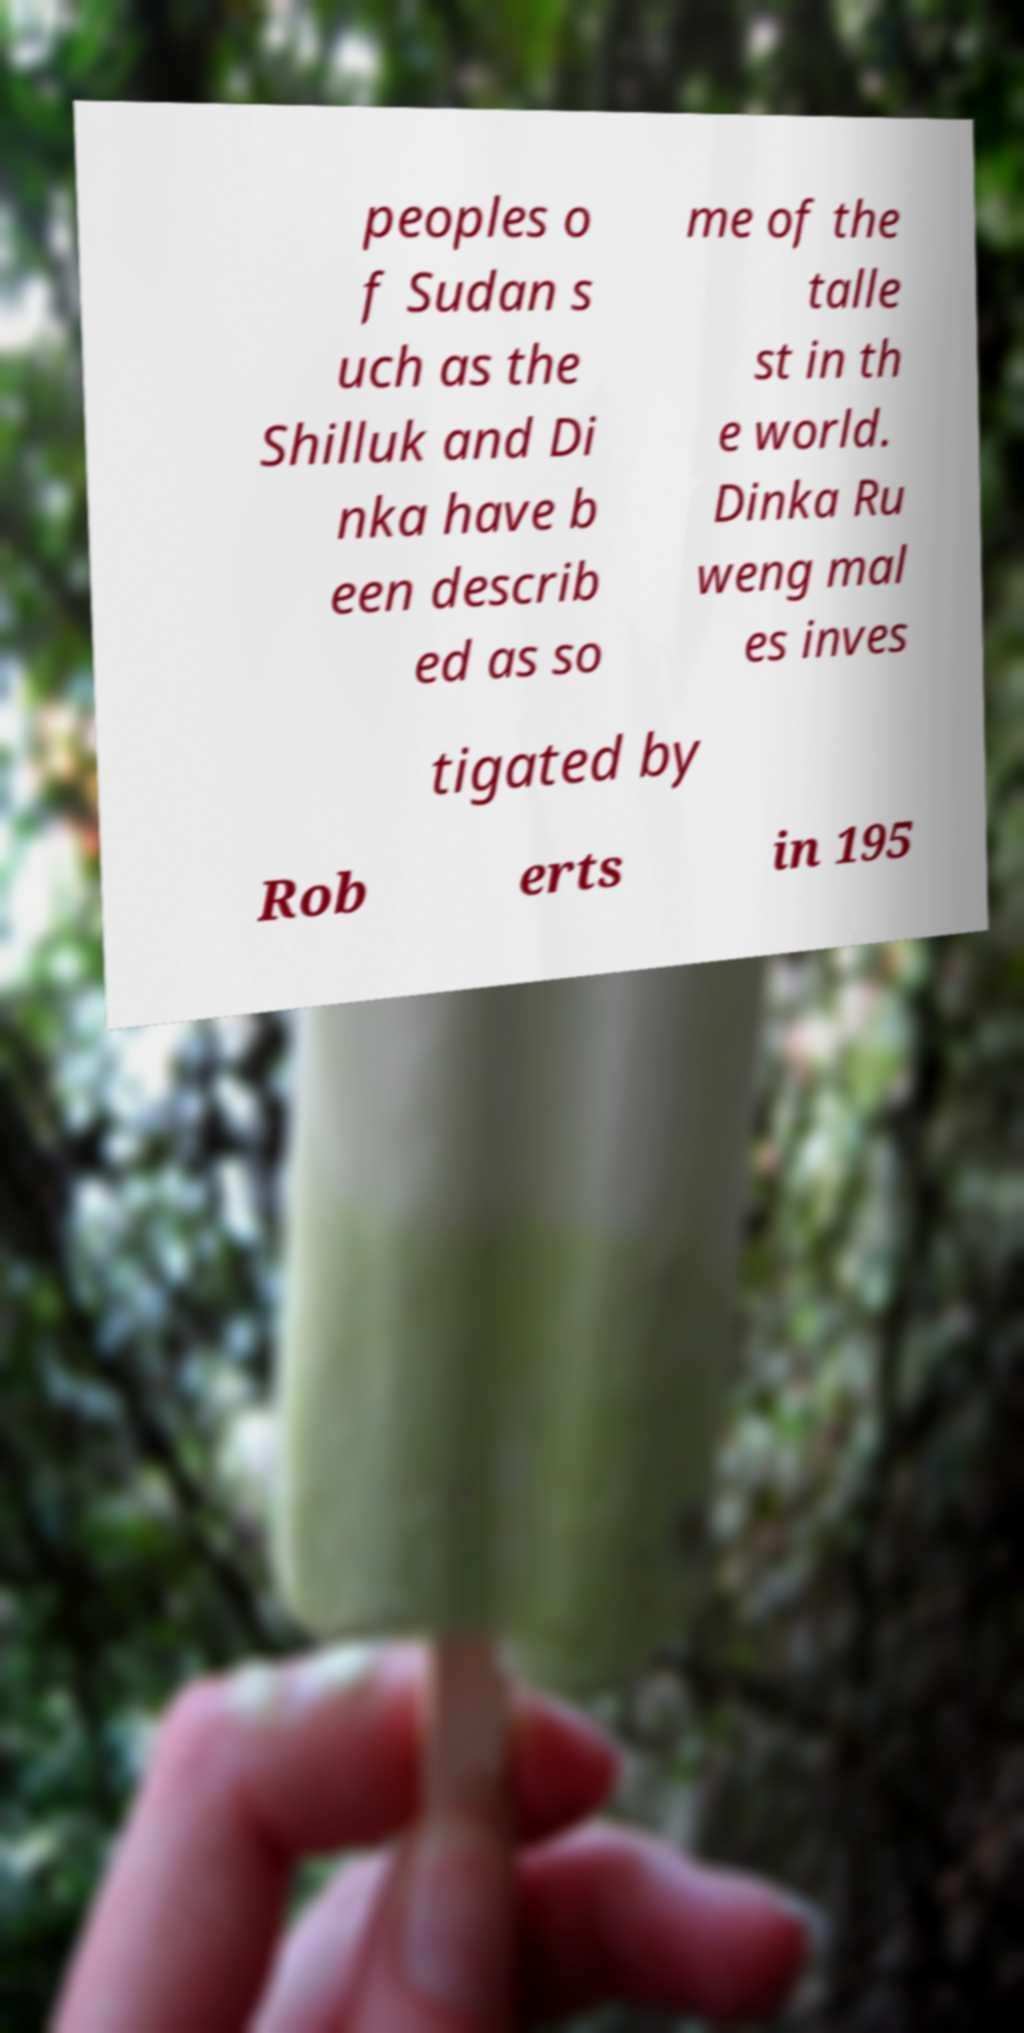Can you accurately transcribe the text from the provided image for me? peoples o f Sudan s uch as the Shilluk and Di nka have b een describ ed as so me of the talle st in th e world. Dinka Ru weng mal es inves tigated by Rob erts in 195 